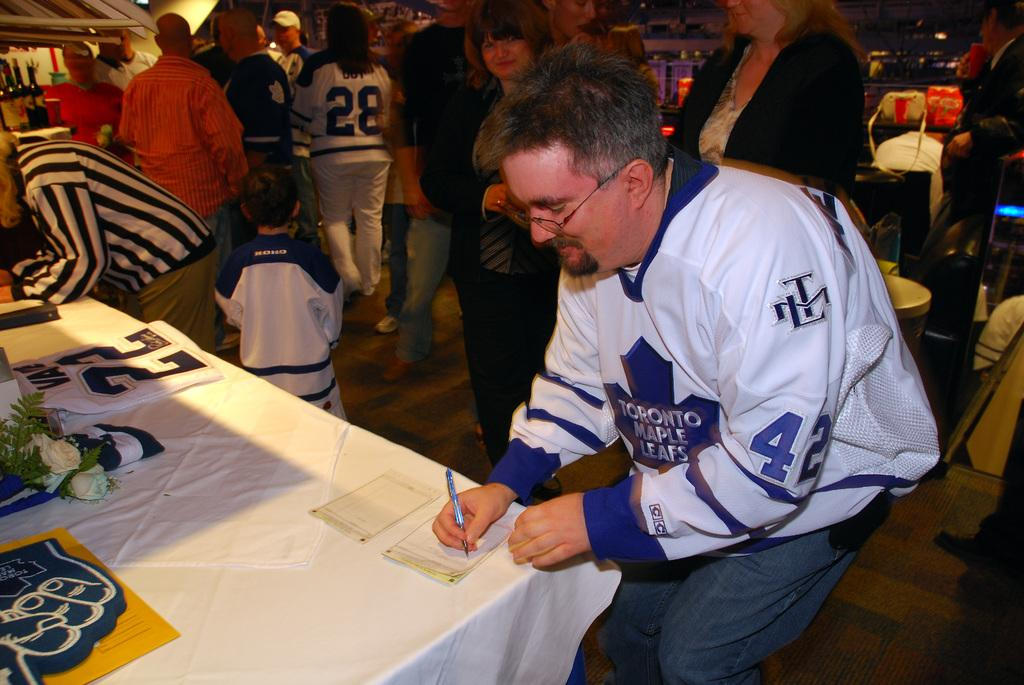<image>
Render a clear and concise summary of the photo. a man in a Toronto Maple Leafs jersey signing something on a table 